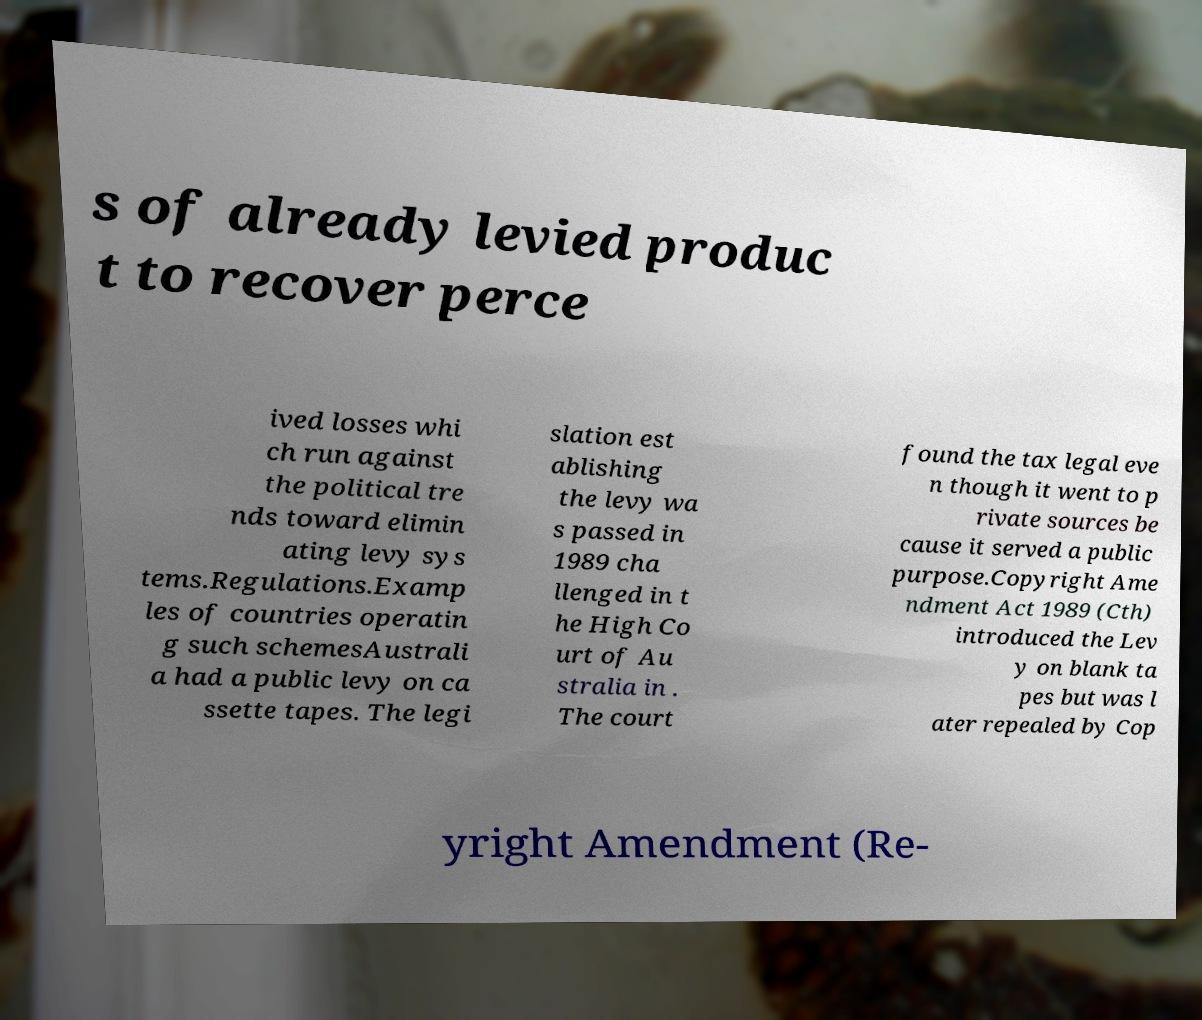Could you extract and type out the text from this image? s of already levied produc t to recover perce ived losses whi ch run against the political tre nds toward elimin ating levy sys tems.Regulations.Examp les of countries operatin g such schemesAustrali a had a public levy on ca ssette tapes. The legi slation est ablishing the levy wa s passed in 1989 cha llenged in t he High Co urt of Au stralia in . The court found the tax legal eve n though it went to p rivate sources be cause it served a public purpose.Copyright Ame ndment Act 1989 (Cth) introduced the Lev y on blank ta pes but was l ater repealed by Cop yright Amendment (Re- 